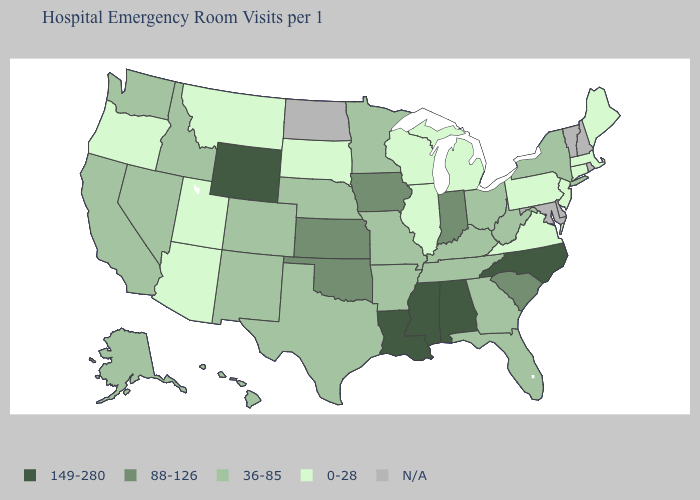Name the states that have a value in the range N/A?
Concise answer only. Delaware, Maryland, New Hampshire, North Dakota, Rhode Island, Vermont. Does Iowa have the highest value in the MidWest?
Write a very short answer. Yes. What is the value of South Carolina?
Be succinct. 88-126. What is the value of Montana?
Answer briefly. 0-28. What is the highest value in states that border Utah?
Give a very brief answer. 149-280. Name the states that have a value in the range N/A?
Keep it brief. Delaware, Maryland, New Hampshire, North Dakota, Rhode Island, Vermont. Which states have the highest value in the USA?
Write a very short answer. Alabama, Louisiana, Mississippi, North Carolina, Wyoming. What is the value of Wyoming?
Quick response, please. 149-280. What is the highest value in the USA?
Quick response, please. 149-280. Name the states that have a value in the range N/A?
Give a very brief answer. Delaware, Maryland, New Hampshire, North Dakota, Rhode Island, Vermont. Which states have the highest value in the USA?
Write a very short answer. Alabama, Louisiana, Mississippi, North Carolina, Wyoming. Does Alabama have the highest value in the USA?
Be succinct. Yes. Name the states that have a value in the range 0-28?
Be succinct. Arizona, Connecticut, Illinois, Maine, Massachusetts, Michigan, Montana, New Jersey, Oregon, Pennsylvania, South Dakota, Utah, Virginia, Wisconsin. 